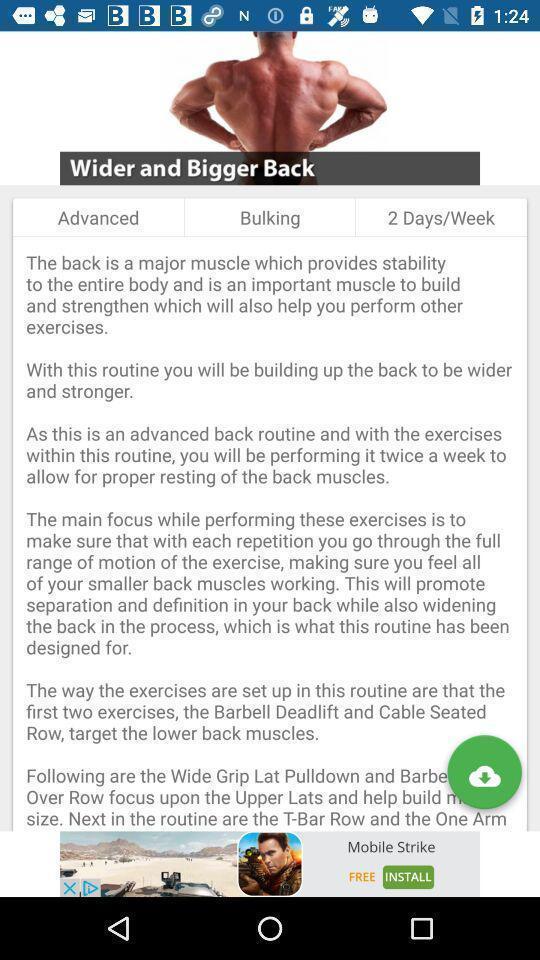Provide a description of this screenshot. Page shows the article of wider and bigger back. 